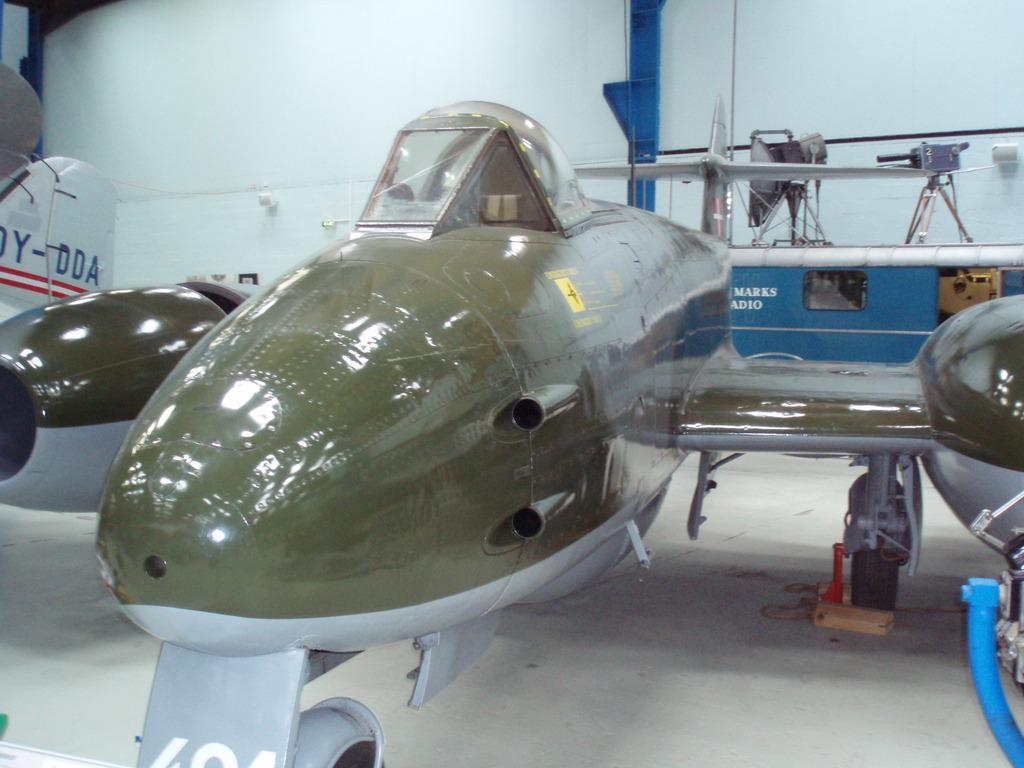<image>
Share a concise interpretation of the image provided. the letters DDA are on the side of one of the planes 